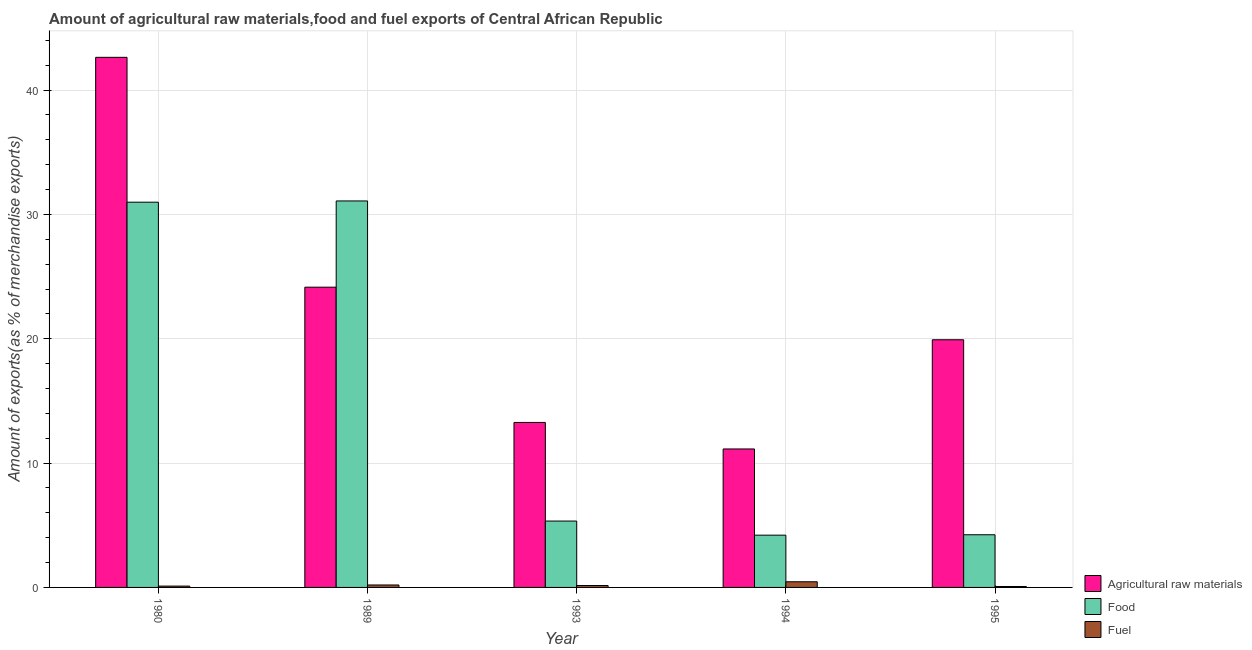How many groups of bars are there?
Offer a very short reply. 5. How many bars are there on the 1st tick from the left?
Provide a succinct answer. 3. How many bars are there on the 4th tick from the right?
Your response must be concise. 3. What is the label of the 1st group of bars from the left?
Your response must be concise. 1980. What is the percentage of raw materials exports in 1989?
Offer a terse response. 24.15. Across all years, what is the maximum percentage of food exports?
Provide a succinct answer. 31.08. Across all years, what is the minimum percentage of food exports?
Offer a terse response. 4.2. In which year was the percentage of raw materials exports minimum?
Offer a very short reply. 1994. What is the total percentage of food exports in the graph?
Keep it short and to the point. 75.84. What is the difference between the percentage of food exports in 1980 and that in 1994?
Provide a succinct answer. 26.78. What is the difference between the percentage of raw materials exports in 1980 and the percentage of food exports in 1995?
Your answer should be compact. 22.71. What is the average percentage of fuel exports per year?
Provide a succinct answer. 0.2. In how many years, is the percentage of raw materials exports greater than 32 %?
Provide a short and direct response. 1. What is the ratio of the percentage of fuel exports in 1980 to that in 1993?
Ensure brevity in your answer.  0.7. Is the percentage of raw materials exports in 1989 less than that in 1995?
Your answer should be compact. No. Is the difference between the percentage of raw materials exports in 1989 and 1993 greater than the difference between the percentage of fuel exports in 1989 and 1993?
Offer a terse response. No. What is the difference between the highest and the second highest percentage of food exports?
Offer a terse response. 0.1. What is the difference between the highest and the lowest percentage of raw materials exports?
Make the answer very short. 31.5. In how many years, is the percentage of food exports greater than the average percentage of food exports taken over all years?
Offer a terse response. 2. Is the sum of the percentage of fuel exports in 1980 and 1994 greater than the maximum percentage of raw materials exports across all years?
Provide a succinct answer. Yes. What does the 1st bar from the left in 1993 represents?
Your answer should be compact. Agricultural raw materials. What does the 3rd bar from the right in 1995 represents?
Your response must be concise. Agricultural raw materials. Is it the case that in every year, the sum of the percentage of raw materials exports and percentage of food exports is greater than the percentage of fuel exports?
Provide a short and direct response. Yes. How many bars are there?
Ensure brevity in your answer.  15. Are all the bars in the graph horizontal?
Offer a very short reply. No. What is the difference between two consecutive major ticks on the Y-axis?
Provide a short and direct response. 10. Does the graph contain any zero values?
Keep it short and to the point. No. How are the legend labels stacked?
Make the answer very short. Vertical. What is the title of the graph?
Provide a short and direct response. Amount of agricultural raw materials,food and fuel exports of Central African Republic. Does "Social Protection and Labor" appear as one of the legend labels in the graph?
Give a very brief answer. No. What is the label or title of the Y-axis?
Your response must be concise. Amount of exports(as % of merchandise exports). What is the Amount of exports(as % of merchandise exports) in Agricultural raw materials in 1980?
Your answer should be very brief. 42.63. What is the Amount of exports(as % of merchandise exports) in Food in 1980?
Your answer should be compact. 30.98. What is the Amount of exports(as % of merchandise exports) in Fuel in 1980?
Ensure brevity in your answer.  0.11. What is the Amount of exports(as % of merchandise exports) of Agricultural raw materials in 1989?
Your answer should be compact. 24.15. What is the Amount of exports(as % of merchandise exports) of Food in 1989?
Provide a short and direct response. 31.08. What is the Amount of exports(as % of merchandise exports) of Fuel in 1989?
Offer a very short reply. 0.2. What is the Amount of exports(as % of merchandise exports) in Agricultural raw materials in 1993?
Provide a short and direct response. 13.27. What is the Amount of exports(as % of merchandise exports) in Food in 1993?
Your answer should be very brief. 5.34. What is the Amount of exports(as % of merchandise exports) in Fuel in 1993?
Offer a terse response. 0.15. What is the Amount of exports(as % of merchandise exports) of Agricultural raw materials in 1994?
Keep it short and to the point. 11.14. What is the Amount of exports(as % of merchandise exports) in Food in 1994?
Provide a short and direct response. 4.2. What is the Amount of exports(as % of merchandise exports) in Fuel in 1994?
Keep it short and to the point. 0.45. What is the Amount of exports(as % of merchandise exports) in Agricultural raw materials in 1995?
Give a very brief answer. 19.92. What is the Amount of exports(as % of merchandise exports) in Food in 1995?
Provide a succinct answer. 4.24. What is the Amount of exports(as % of merchandise exports) of Fuel in 1995?
Your answer should be compact. 0.08. Across all years, what is the maximum Amount of exports(as % of merchandise exports) in Agricultural raw materials?
Your answer should be very brief. 42.63. Across all years, what is the maximum Amount of exports(as % of merchandise exports) of Food?
Your answer should be compact. 31.08. Across all years, what is the maximum Amount of exports(as % of merchandise exports) in Fuel?
Offer a very short reply. 0.45. Across all years, what is the minimum Amount of exports(as % of merchandise exports) of Agricultural raw materials?
Your answer should be compact. 11.14. Across all years, what is the minimum Amount of exports(as % of merchandise exports) in Food?
Give a very brief answer. 4.2. Across all years, what is the minimum Amount of exports(as % of merchandise exports) in Fuel?
Provide a short and direct response. 0.08. What is the total Amount of exports(as % of merchandise exports) in Agricultural raw materials in the graph?
Your answer should be very brief. 111.11. What is the total Amount of exports(as % of merchandise exports) in Food in the graph?
Ensure brevity in your answer.  75.84. What is the difference between the Amount of exports(as % of merchandise exports) of Agricultural raw materials in 1980 and that in 1989?
Your response must be concise. 18.49. What is the difference between the Amount of exports(as % of merchandise exports) in Food in 1980 and that in 1989?
Offer a terse response. -0.1. What is the difference between the Amount of exports(as % of merchandise exports) in Fuel in 1980 and that in 1989?
Your answer should be compact. -0.09. What is the difference between the Amount of exports(as % of merchandise exports) of Agricultural raw materials in 1980 and that in 1993?
Your response must be concise. 29.37. What is the difference between the Amount of exports(as % of merchandise exports) in Food in 1980 and that in 1993?
Provide a short and direct response. 25.64. What is the difference between the Amount of exports(as % of merchandise exports) of Fuel in 1980 and that in 1993?
Offer a very short reply. -0.05. What is the difference between the Amount of exports(as % of merchandise exports) of Agricultural raw materials in 1980 and that in 1994?
Your answer should be very brief. 31.5. What is the difference between the Amount of exports(as % of merchandise exports) in Food in 1980 and that in 1994?
Offer a terse response. 26.78. What is the difference between the Amount of exports(as % of merchandise exports) in Fuel in 1980 and that in 1994?
Provide a succinct answer. -0.35. What is the difference between the Amount of exports(as % of merchandise exports) of Agricultural raw materials in 1980 and that in 1995?
Keep it short and to the point. 22.71. What is the difference between the Amount of exports(as % of merchandise exports) of Food in 1980 and that in 1995?
Give a very brief answer. 26.75. What is the difference between the Amount of exports(as % of merchandise exports) of Fuel in 1980 and that in 1995?
Give a very brief answer. 0.03. What is the difference between the Amount of exports(as % of merchandise exports) of Agricultural raw materials in 1989 and that in 1993?
Ensure brevity in your answer.  10.88. What is the difference between the Amount of exports(as % of merchandise exports) of Food in 1989 and that in 1993?
Provide a short and direct response. 25.74. What is the difference between the Amount of exports(as % of merchandise exports) of Fuel in 1989 and that in 1993?
Offer a very short reply. 0.04. What is the difference between the Amount of exports(as % of merchandise exports) in Agricultural raw materials in 1989 and that in 1994?
Make the answer very short. 13.01. What is the difference between the Amount of exports(as % of merchandise exports) of Food in 1989 and that in 1994?
Your answer should be compact. 26.88. What is the difference between the Amount of exports(as % of merchandise exports) in Fuel in 1989 and that in 1994?
Provide a succinct answer. -0.26. What is the difference between the Amount of exports(as % of merchandise exports) in Agricultural raw materials in 1989 and that in 1995?
Provide a short and direct response. 4.23. What is the difference between the Amount of exports(as % of merchandise exports) in Food in 1989 and that in 1995?
Your response must be concise. 26.85. What is the difference between the Amount of exports(as % of merchandise exports) in Fuel in 1989 and that in 1995?
Your response must be concise. 0.12. What is the difference between the Amount of exports(as % of merchandise exports) in Agricultural raw materials in 1993 and that in 1994?
Your answer should be very brief. 2.13. What is the difference between the Amount of exports(as % of merchandise exports) of Food in 1993 and that in 1994?
Ensure brevity in your answer.  1.13. What is the difference between the Amount of exports(as % of merchandise exports) of Fuel in 1993 and that in 1994?
Your answer should be compact. -0.3. What is the difference between the Amount of exports(as % of merchandise exports) of Agricultural raw materials in 1993 and that in 1995?
Your answer should be compact. -6.65. What is the difference between the Amount of exports(as % of merchandise exports) in Food in 1993 and that in 1995?
Keep it short and to the point. 1.1. What is the difference between the Amount of exports(as % of merchandise exports) in Fuel in 1993 and that in 1995?
Your answer should be compact. 0.08. What is the difference between the Amount of exports(as % of merchandise exports) of Agricultural raw materials in 1994 and that in 1995?
Provide a succinct answer. -8.78. What is the difference between the Amount of exports(as % of merchandise exports) in Food in 1994 and that in 1995?
Make the answer very short. -0.03. What is the difference between the Amount of exports(as % of merchandise exports) in Fuel in 1994 and that in 1995?
Ensure brevity in your answer.  0.38. What is the difference between the Amount of exports(as % of merchandise exports) in Agricultural raw materials in 1980 and the Amount of exports(as % of merchandise exports) in Food in 1989?
Provide a short and direct response. 11.55. What is the difference between the Amount of exports(as % of merchandise exports) of Agricultural raw materials in 1980 and the Amount of exports(as % of merchandise exports) of Fuel in 1989?
Your answer should be very brief. 42.44. What is the difference between the Amount of exports(as % of merchandise exports) of Food in 1980 and the Amount of exports(as % of merchandise exports) of Fuel in 1989?
Provide a succinct answer. 30.79. What is the difference between the Amount of exports(as % of merchandise exports) in Agricultural raw materials in 1980 and the Amount of exports(as % of merchandise exports) in Food in 1993?
Offer a terse response. 37.3. What is the difference between the Amount of exports(as % of merchandise exports) of Agricultural raw materials in 1980 and the Amount of exports(as % of merchandise exports) of Fuel in 1993?
Make the answer very short. 42.48. What is the difference between the Amount of exports(as % of merchandise exports) of Food in 1980 and the Amount of exports(as % of merchandise exports) of Fuel in 1993?
Offer a terse response. 30.83. What is the difference between the Amount of exports(as % of merchandise exports) of Agricultural raw materials in 1980 and the Amount of exports(as % of merchandise exports) of Food in 1994?
Provide a succinct answer. 38.43. What is the difference between the Amount of exports(as % of merchandise exports) of Agricultural raw materials in 1980 and the Amount of exports(as % of merchandise exports) of Fuel in 1994?
Ensure brevity in your answer.  42.18. What is the difference between the Amount of exports(as % of merchandise exports) of Food in 1980 and the Amount of exports(as % of merchandise exports) of Fuel in 1994?
Your answer should be compact. 30.53. What is the difference between the Amount of exports(as % of merchandise exports) of Agricultural raw materials in 1980 and the Amount of exports(as % of merchandise exports) of Food in 1995?
Offer a terse response. 38.4. What is the difference between the Amount of exports(as % of merchandise exports) in Agricultural raw materials in 1980 and the Amount of exports(as % of merchandise exports) in Fuel in 1995?
Provide a succinct answer. 42.56. What is the difference between the Amount of exports(as % of merchandise exports) of Food in 1980 and the Amount of exports(as % of merchandise exports) of Fuel in 1995?
Ensure brevity in your answer.  30.91. What is the difference between the Amount of exports(as % of merchandise exports) of Agricultural raw materials in 1989 and the Amount of exports(as % of merchandise exports) of Food in 1993?
Your response must be concise. 18.81. What is the difference between the Amount of exports(as % of merchandise exports) of Agricultural raw materials in 1989 and the Amount of exports(as % of merchandise exports) of Fuel in 1993?
Keep it short and to the point. 23.99. What is the difference between the Amount of exports(as % of merchandise exports) in Food in 1989 and the Amount of exports(as % of merchandise exports) in Fuel in 1993?
Make the answer very short. 30.93. What is the difference between the Amount of exports(as % of merchandise exports) in Agricultural raw materials in 1989 and the Amount of exports(as % of merchandise exports) in Food in 1994?
Give a very brief answer. 19.94. What is the difference between the Amount of exports(as % of merchandise exports) in Agricultural raw materials in 1989 and the Amount of exports(as % of merchandise exports) in Fuel in 1994?
Provide a short and direct response. 23.69. What is the difference between the Amount of exports(as % of merchandise exports) in Food in 1989 and the Amount of exports(as % of merchandise exports) in Fuel in 1994?
Make the answer very short. 30.63. What is the difference between the Amount of exports(as % of merchandise exports) of Agricultural raw materials in 1989 and the Amount of exports(as % of merchandise exports) of Food in 1995?
Ensure brevity in your answer.  19.91. What is the difference between the Amount of exports(as % of merchandise exports) of Agricultural raw materials in 1989 and the Amount of exports(as % of merchandise exports) of Fuel in 1995?
Give a very brief answer. 24.07. What is the difference between the Amount of exports(as % of merchandise exports) in Food in 1989 and the Amount of exports(as % of merchandise exports) in Fuel in 1995?
Offer a terse response. 31.01. What is the difference between the Amount of exports(as % of merchandise exports) in Agricultural raw materials in 1993 and the Amount of exports(as % of merchandise exports) in Food in 1994?
Offer a very short reply. 9.06. What is the difference between the Amount of exports(as % of merchandise exports) of Agricultural raw materials in 1993 and the Amount of exports(as % of merchandise exports) of Fuel in 1994?
Your answer should be compact. 12.81. What is the difference between the Amount of exports(as % of merchandise exports) of Food in 1993 and the Amount of exports(as % of merchandise exports) of Fuel in 1994?
Provide a short and direct response. 4.88. What is the difference between the Amount of exports(as % of merchandise exports) in Agricultural raw materials in 1993 and the Amount of exports(as % of merchandise exports) in Food in 1995?
Ensure brevity in your answer.  9.03. What is the difference between the Amount of exports(as % of merchandise exports) in Agricultural raw materials in 1993 and the Amount of exports(as % of merchandise exports) in Fuel in 1995?
Offer a very short reply. 13.19. What is the difference between the Amount of exports(as % of merchandise exports) of Food in 1993 and the Amount of exports(as % of merchandise exports) of Fuel in 1995?
Offer a terse response. 5.26. What is the difference between the Amount of exports(as % of merchandise exports) in Agricultural raw materials in 1994 and the Amount of exports(as % of merchandise exports) in Food in 1995?
Your response must be concise. 6.9. What is the difference between the Amount of exports(as % of merchandise exports) in Agricultural raw materials in 1994 and the Amount of exports(as % of merchandise exports) in Fuel in 1995?
Make the answer very short. 11.06. What is the difference between the Amount of exports(as % of merchandise exports) in Food in 1994 and the Amount of exports(as % of merchandise exports) in Fuel in 1995?
Keep it short and to the point. 4.13. What is the average Amount of exports(as % of merchandise exports) of Agricultural raw materials per year?
Ensure brevity in your answer.  22.22. What is the average Amount of exports(as % of merchandise exports) of Food per year?
Make the answer very short. 15.17. What is the average Amount of exports(as % of merchandise exports) of Fuel per year?
Offer a terse response. 0.2. In the year 1980, what is the difference between the Amount of exports(as % of merchandise exports) in Agricultural raw materials and Amount of exports(as % of merchandise exports) in Food?
Offer a very short reply. 11.65. In the year 1980, what is the difference between the Amount of exports(as % of merchandise exports) in Agricultural raw materials and Amount of exports(as % of merchandise exports) in Fuel?
Provide a short and direct response. 42.53. In the year 1980, what is the difference between the Amount of exports(as % of merchandise exports) of Food and Amount of exports(as % of merchandise exports) of Fuel?
Provide a succinct answer. 30.87. In the year 1989, what is the difference between the Amount of exports(as % of merchandise exports) of Agricultural raw materials and Amount of exports(as % of merchandise exports) of Food?
Provide a short and direct response. -6.93. In the year 1989, what is the difference between the Amount of exports(as % of merchandise exports) of Agricultural raw materials and Amount of exports(as % of merchandise exports) of Fuel?
Provide a succinct answer. 23.95. In the year 1989, what is the difference between the Amount of exports(as % of merchandise exports) of Food and Amount of exports(as % of merchandise exports) of Fuel?
Your answer should be compact. 30.89. In the year 1993, what is the difference between the Amount of exports(as % of merchandise exports) of Agricultural raw materials and Amount of exports(as % of merchandise exports) of Food?
Provide a short and direct response. 7.93. In the year 1993, what is the difference between the Amount of exports(as % of merchandise exports) of Agricultural raw materials and Amount of exports(as % of merchandise exports) of Fuel?
Make the answer very short. 13.11. In the year 1993, what is the difference between the Amount of exports(as % of merchandise exports) in Food and Amount of exports(as % of merchandise exports) in Fuel?
Keep it short and to the point. 5.18. In the year 1994, what is the difference between the Amount of exports(as % of merchandise exports) of Agricultural raw materials and Amount of exports(as % of merchandise exports) of Food?
Keep it short and to the point. 6.93. In the year 1994, what is the difference between the Amount of exports(as % of merchandise exports) in Agricultural raw materials and Amount of exports(as % of merchandise exports) in Fuel?
Make the answer very short. 10.68. In the year 1994, what is the difference between the Amount of exports(as % of merchandise exports) in Food and Amount of exports(as % of merchandise exports) in Fuel?
Offer a terse response. 3.75. In the year 1995, what is the difference between the Amount of exports(as % of merchandise exports) in Agricultural raw materials and Amount of exports(as % of merchandise exports) in Food?
Your answer should be very brief. 15.68. In the year 1995, what is the difference between the Amount of exports(as % of merchandise exports) in Agricultural raw materials and Amount of exports(as % of merchandise exports) in Fuel?
Make the answer very short. 19.84. In the year 1995, what is the difference between the Amount of exports(as % of merchandise exports) of Food and Amount of exports(as % of merchandise exports) of Fuel?
Provide a short and direct response. 4.16. What is the ratio of the Amount of exports(as % of merchandise exports) in Agricultural raw materials in 1980 to that in 1989?
Offer a terse response. 1.77. What is the ratio of the Amount of exports(as % of merchandise exports) of Fuel in 1980 to that in 1989?
Provide a short and direct response. 0.55. What is the ratio of the Amount of exports(as % of merchandise exports) of Agricultural raw materials in 1980 to that in 1993?
Your answer should be very brief. 3.21. What is the ratio of the Amount of exports(as % of merchandise exports) in Food in 1980 to that in 1993?
Offer a very short reply. 5.8. What is the ratio of the Amount of exports(as % of merchandise exports) in Fuel in 1980 to that in 1993?
Your response must be concise. 0.7. What is the ratio of the Amount of exports(as % of merchandise exports) of Agricultural raw materials in 1980 to that in 1994?
Offer a terse response. 3.83. What is the ratio of the Amount of exports(as % of merchandise exports) of Food in 1980 to that in 1994?
Offer a very short reply. 7.37. What is the ratio of the Amount of exports(as % of merchandise exports) of Fuel in 1980 to that in 1994?
Your answer should be compact. 0.24. What is the ratio of the Amount of exports(as % of merchandise exports) of Agricultural raw materials in 1980 to that in 1995?
Your answer should be compact. 2.14. What is the ratio of the Amount of exports(as % of merchandise exports) of Food in 1980 to that in 1995?
Your answer should be very brief. 7.31. What is the ratio of the Amount of exports(as % of merchandise exports) of Fuel in 1980 to that in 1995?
Offer a very short reply. 1.44. What is the ratio of the Amount of exports(as % of merchandise exports) of Agricultural raw materials in 1989 to that in 1993?
Provide a succinct answer. 1.82. What is the ratio of the Amount of exports(as % of merchandise exports) of Food in 1989 to that in 1993?
Provide a short and direct response. 5.82. What is the ratio of the Amount of exports(as % of merchandise exports) of Fuel in 1989 to that in 1993?
Your answer should be compact. 1.28. What is the ratio of the Amount of exports(as % of merchandise exports) in Agricultural raw materials in 1989 to that in 1994?
Ensure brevity in your answer.  2.17. What is the ratio of the Amount of exports(as % of merchandise exports) in Food in 1989 to that in 1994?
Keep it short and to the point. 7.39. What is the ratio of the Amount of exports(as % of merchandise exports) in Fuel in 1989 to that in 1994?
Give a very brief answer. 0.43. What is the ratio of the Amount of exports(as % of merchandise exports) of Agricultural raw materials in 1989 to that in 1995?
Offer a very short reply. 1.21. What is the ratio of the Amount of exports(as % of merchandise exports) in Food in 1989 to that in 1995?
Ensure brevity in your answer.  7.34. What is the ratio of the Amount of exports(as % of merchandise exports) of Fuel in 1989 to that in 1995?
Keep it short and to the point. 2.61. What is the ratio of the Amount of exports(as % of merchandise exports) of Agricultural raw materials in 1993 to that in 1994?
Provide a succinct answer. 1.19. What is the ratio of the Amount of exports(as % of merchandise exports) of Food in 1993 to that in 1994?
Your answer should be compact. 1.27. What is the ratio of the Amount of exports(as % of merchandise exports) in Fuel in 1993 to that in 1994?
Your response must be concise. 0.34. What is the ratio of the Amount of exports(as % of merchandise exports) of Agricultural raw materials in 1993 to that in 1995?
Keep it short and to the point. 0.67. What is the ratio of the Amount of exports(as % of merchandise exports) of Food in 1993 to that in 1995?
Your answer should be very brief. 1.26. What is the ratio of the Amount of exports(as % of merchandise exports) of Fuel in 1993 to that in 1995?
Offer a terse response. 2.04. What is the ratio of the Amount of exports(as % of merchandise exports) in Agricultural raw materials in 1994 to that in 1995?
Offer a terse response. 0.56. What is the ratio of the Amount of exports(as % of merchandise exports) of Fuel in 1994 to that in 1995?
Offer a very short reply. 6.02. What is the difference between the highest and the second highest Amount of exports(as % of merchandise exports) of Agricultural raw materials?
Provide a succinct answer. 18.49. What is the difference between the highest and the second highest Amount of exports(as % of merchandise exports) of Food?
Give a very brief answer. 0.1. What is the difference between the highest and the second highest Amount of exports(as % of merchandise exports) of Fuel?
Your answer should be compact. 0.26. What is the difference between the highest and the lowest Amount of exports(as % of merchandise exports) of Agricultural raw materials?
Offer a terse response. 31.5. What is the difference between the highest and the lowest Amount of exports(as % of merchandise exports) in Food?
Ensure brevity in your answer.  26.88. What is the difference between the highest and the lowest Amount of exports(as % of merchandise exports) of Fuel?
Provide a succinct answer. 0.38. 